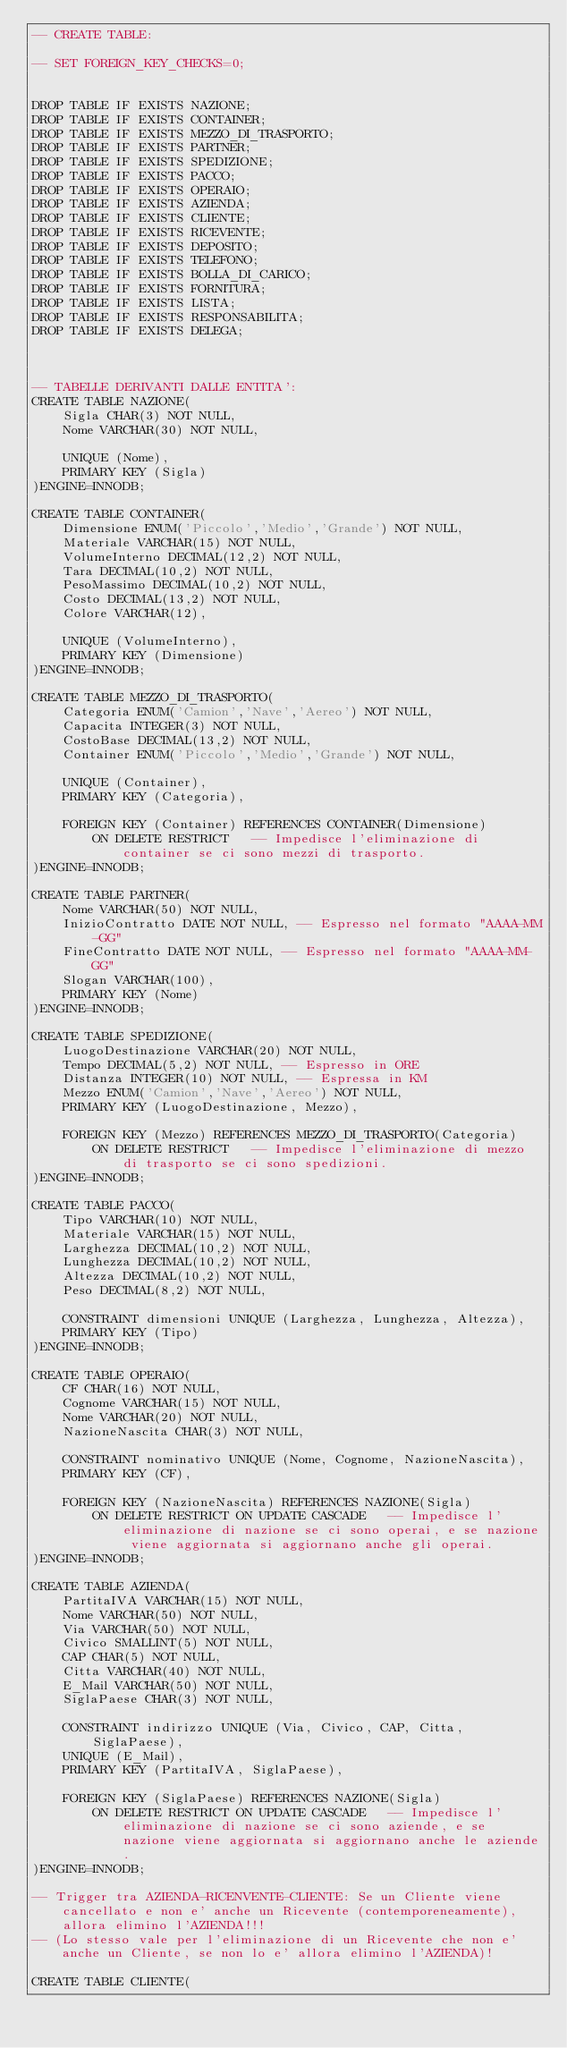Convert code to text. <code><loc_0><loc_0><loc_500><loc_500><_SQL_>-- CREATE TABLE:

-- SET FOREIGN_KEY_CHECKS=0;


DROP TABLE IF EXISTS NAZIONE;
DROP TABLE IF EXISTS CONTAINER;
DROP TABLE IF EXISTS MEZZO_DI_TRASPORTO;
DROP TABLE IF EXISTS PARTNER;
DROP TABLE IF EXISTS SPEDIZIONE;
DROP TABLE IF EXISTS PACCO;
DROP TABLE IF EXISTS OPERAIO;
DROP TABLE IF EXISTS AZIENDA;
DROP TABLE IF EXISTS CLIENTE;
DROP TABLE IF EXISTS RICEVENTE;
DROP TABLE IF EXISTS DEPOSITO;
DROP TABLE IF EXISTS TELEFONO;
DROP TABLE IF EXISTS BOLLA_DI_CARICO;
DROP TABLE IF EXISTS FORNITURA;
DROP TABLE IF EXISTS LISTA;
DROP TABLE IF EXISTS RESPONSABILITA;
DROP TABLE IF EXISTS DELEGA;



-- TABELLE DERIVANTI DALLE ENTITA':
CREATE TABLE NAZIONE(
	Sigla CHAR(3) NOT NULL,
	Nome VARCHAR(30) NOT NULL,
	
	UNIQUE (Nome),
	PRIMARY KEY (Sigla)
)ENGINE=INNODB;

CREATE TABLE CONTAINER(
	Dimensione ENUM('Piccolo','Medio','Grande') NOT NULL,
	Materiale VARCHAR(15) NOT NULL,
	VolumeInterno DECIMAL(12,2) NOT NULL,
	Tara DECIMAL(10,2) NOT NULL,
	PesoMassimo DECIMAL(10,2) NOT NULL,
	Costo DECIMAL(13,2) NOT NULL,
	Colore VARCHAR(12),
	
	UNIQUE (VolumeInterno),
	PRIMARY KEY (Dimensione)
)ENGINE=INNODB;

CREATE TABLE MEZZO_DI_TRASPORTO(
	Categoria ENUM('Camion','Nave','Aereo') NOT NULL,
	Capacita INTEGER(3) NOT NULL,
	CostoBase DECIMAL(13,2) NOT NULL,
	Container ENUM('Piccolo','Medio','Grande') NOT NULL,
	
	UNIQUE (Container),
	PRIMARY KEY (Categoria),
	
	FOREIGN KEY (Container) REFERENCES CONTAINER(Dimensione)
		ON DELETE RESTRICT   -- Impedisce l'eliminazione di container se ci sono mezzi di trasporto.
)ENGINE=INNODB;

CREATE TABLE PARTNER(
	Nome VARCHAR(50) NOT NULL,
	InizioContratto DATE NOT NULL, -- Espresso nel formato "AAAA-MM-GG"
	FineContratto DATE NOT NULL, -- Espresso nel formato "AAAA-MM-GG"
	Slogan VARCHAR(100),
	PRIMARY KEY (Nome)
)ENGINE=INNODB;

CREATE TABLE SPEDIZIONE(
	LuogoDestinazione VARCHAR(20) NOT NULL,
	Tempo DECIMAL(5,2) NOT NULL, -- Espresso in ORE
	Distanza INTEGER(10) NOT NULL, -- Espressa in KM
	Mezzo ENUM('Camion','Nave','Aereo') NOT NULL,
	PRIMARY KEY (LuogoDestinazione, Mezzo),
	
	FOREIGN KEY (Mezzo) REFERENCES MEZZO_DI_TRASPORTO(Categoria)
		ON DELETE RESTRICT   -- Impedisce l'eliminazione di mezzo di trasporto se ci sono spedizioni.
)ENGINE=INNODB;

CREATE TABLE PACCO(
	Tipo VARCHAR(10) NOT NULL,
	Materiale VARCHAR(15) NOT NULL,
	Larghezza DECIMAL(10,2) NOT NULL,
	Lunghezza DECIMAL(10,2) NOT NULL,
	Altezza DECIMAL(10,2) NOT NULL,
	Peso DECIMAL(8,2) NOT NULL,
	
	CONSTRAINT dimensioni UNIQUE (Larghezza, Lunghezza, Altezza),
	PRIMARY KEY (Tipo)
)ENGINE=INNODB;

CREATE TABLE OPERAIO(
	CF CHAR(16) NOT NULL,
	Cognome VARCHAR(15) NOT NULL,
	Nome VARCHAR(20) NOT NULL,
	NazioneNascita CHAR(3) NOT NULL,
	
	CONSTRAINT nominativo UNIQUE (Nome, Cognome, NazioneNascita),
	PRIMARY KEY (CF),
	
	FOREIGN KEY (NazioneNascita) REFERENCES NAZIONE(Sigla)
		ON DELETE RESTRICT ON UPDATE CASCADE   -- Impedisce l'eliminazione di nazione se ci sono operai, e se nazione viene aggiornata si aggiornano anche gli operai.
)ENGINE=INNODB;

CREATE TABLE AZIENDA(
	PartitaIVA VARCHAR(15) NOT NULL,
	Nome VARCHAR(50) NOT NULL,
	Via VARCHAR(50) NOT NULL,
	Civico SMALLINT(5) NOT NULL,
	CAP CHAR(5) NOT NULL,
	Citta VARCHAR(40) NOT NULL,
	E_Mail VARCHAR(50) NOT NULL,
	SiglaPaese CHAR(3) NOT NULL,
	
	CONSTRAINT indirizzo UNIQUE (Via, Civico, CAP, Citta, SiglaPaese),
	UNIQUE (E_Mail),
	PRIMARY KEY (PartitaIVA, SiglaPaese),
	
	FOREIGN KEY (SiglaPaese) REFERENCES NAZIONE(Sigla)
		ON DELETE RESTRICT ON UPDATE CASCADE   -- Impedisce l'eliminazione di nazione se ci sono aziende, e se nazione viene aggiornata si aggiornano anche le aziende.
)ENGINE=INNODB;

-- Trigger tra AZIENDA-RICENVENTE-CLIENTE: Se un Cliente viene cancellato e non e' anche un Ricevente (contemporeneamente), allora elimino l'AZIENDA!!!
-- (Lo stesso vale per l'eliminazione di un Ricevente che non e' anche un Cliente, se non lo e' allora elimino l'AZIENDA)!

CREATE TABLE CLIENTE(</code> 